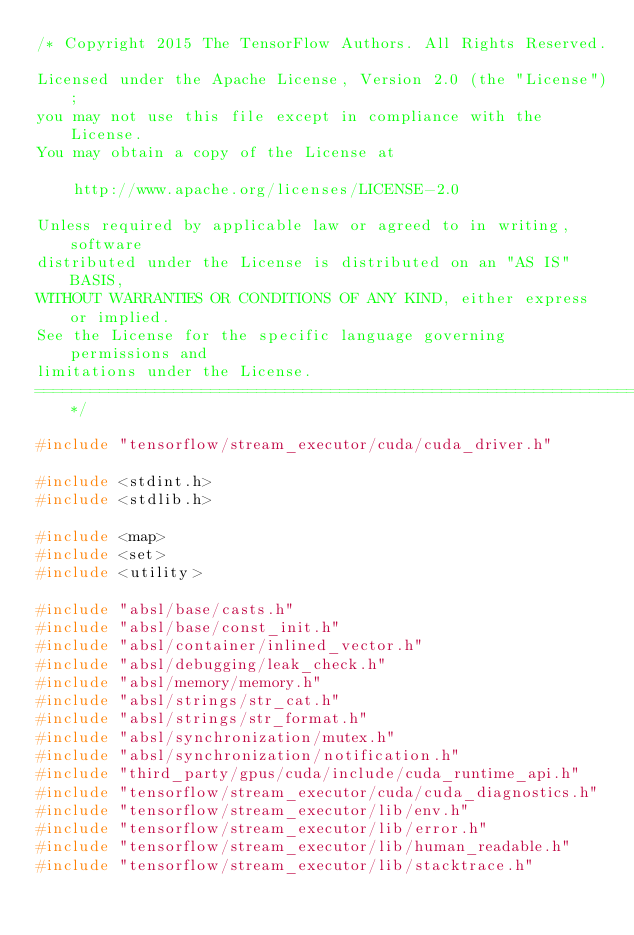<code> <loc_0><loc_0><loc_500><loc_500><_C++_>/* Copyright 2015 The TensorFlow Authors. All Rights Reserved.

Licensed under the Apache License, Version 2.0 (the "License");
you may not use this file except in compliance with the License.
You may obtain a copy of the License at

    http://www.apache.org/licenses/LICENSE-2.0

Unless required by applicable law or agreed to in writing, software
distributed under the License is distributed on an "AS IS" BASIS,
WITHOUT WARRANTIES OR CONDITIONS OF ANY KIND, either express or implied.
See the License for the specific language governing permissions and
limitations under the License.
==============================================================================*/

#include "tensorflow/stream_executor/cuda/cuda_driver.h"

#include <stdint.h>
#include <stdlib.h>

#include <map>
#include <set>
#include <utility>

#include "absl/base/casts.h"
#include "absl/base/const_init.h"
#include "absl/container/inlined_vector.h"
#include "absl/debugging/leak_check.h"
#include "absl/memory/memory.h"
#include "absl/strings/str_cat.h"
#include "absl/strings/str_format.h"
#include "absl/synchronization/mutex.h"
#include "absl/synchronization/notification.h"
#include "third_party/gpus/cuda/include/cuda_runtime_api.h"
#include "tensorflow/stream_executor/cuda/cuda_diagnostics.h"
#include "tensorflow/stream_executor/lib/env.h"
#include "tensorflow/stream_executor/lib/error.h"
#include "tensorflow/stream_executor/lib/human_readable.h"
#include "tensorflow/stream_executor/lib/stacktrace.h"</code> 